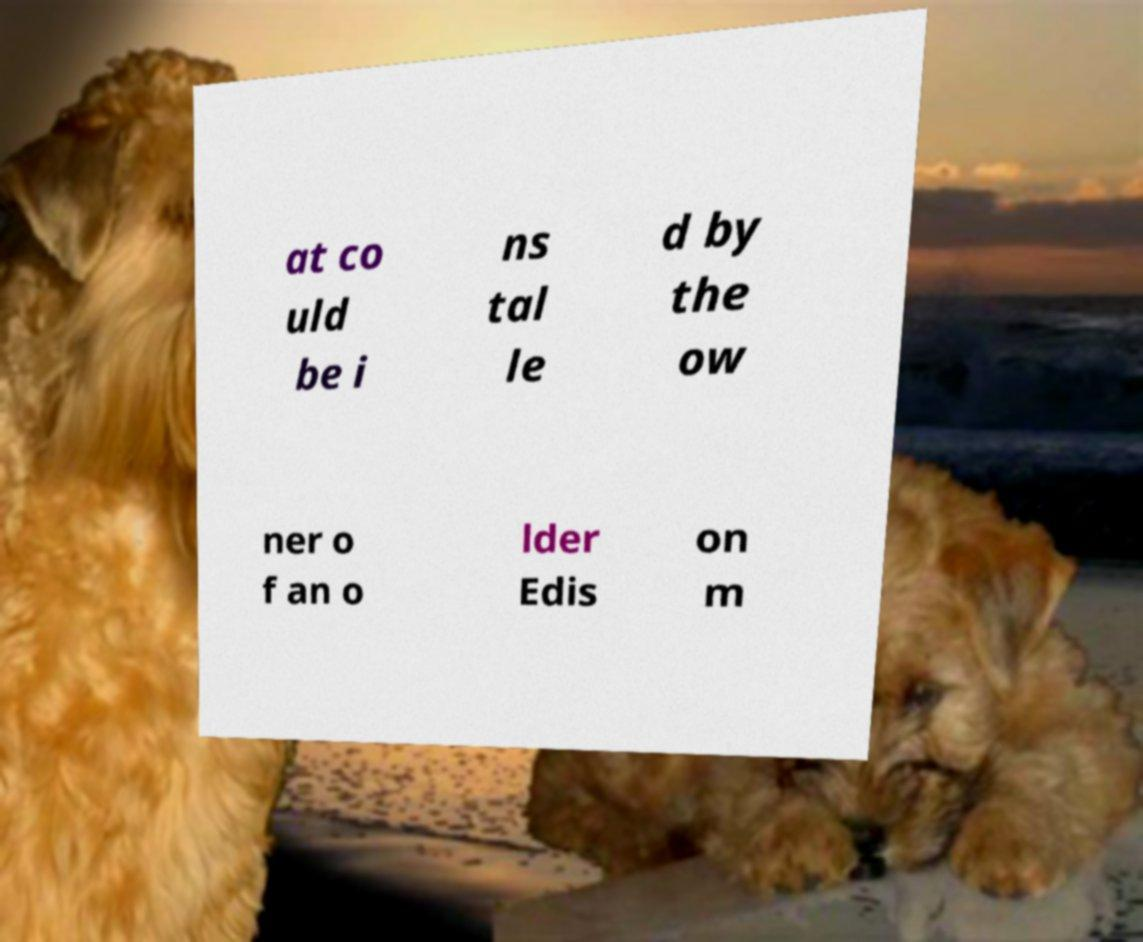Could you extract and type out the text from this image? at co uld be i ns tal le d by the ow ner o f an o lder Edis on m 